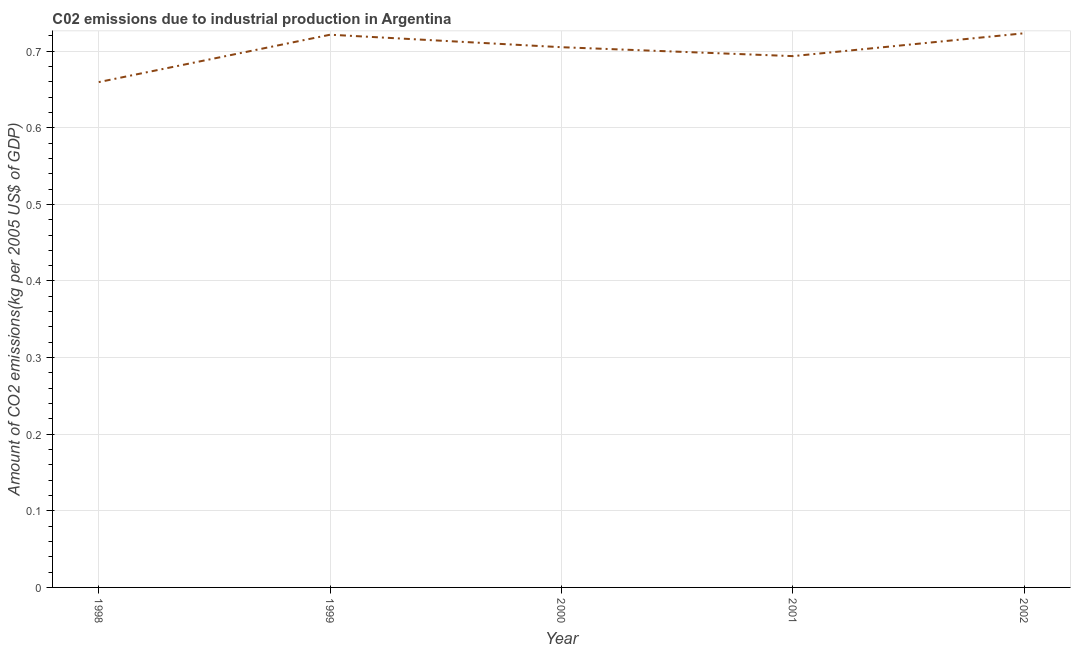What is the amount of co2 emissions in 2001?
Your answer should be very brief. 0.69. Across all years, what is the maximum amount of co2 emissions?
Your response must be concise. 0.72. Across all years, what is the minimum amount of co2 emissions?
Your answer should be very brief. 0.66. What is the sum of the amount of co2 emissions?
Your response must be concise. 3.5. What is the difference between the amount of co2 emissions in 1998 and 2002?
Provide a short and direct response. -0.06. What is the average amount of co2 emissions per year?
Ensure brevity in your answer.  0.7. What is the median amount of co2 emissions?
Keep it short and to the point. 0.71. What is the ratio of the amount of co2 emissions in 1999 to that in 2002?
Your answer should be compact. 1. Is the difference between the amount of co2 emissions in 1999 and 2001 greater than the difference between any two years?
Offer a very short reply. No. What is the difference between the highest and the second highest amount of co2 emissions?
Your answer should be very brief. 0. What is the difference between the highest and the lowest amount of co2 emissions?
Provide a succinct answer. 0.06. In how many years, is the amount of co2 emissions greater than the average amount of co2 emissions taken over all years?
Give a very brief answer. 3. How many lines are there?
Offer a very short reply. 1. Are the values on the major ticks of Y-axis written in scientific E-notation?
Ensure brevity in your answer.  No. What is the title of the graph?
Make the answer very short. C02 emissions due to industrial production in Argentina. What is the label or title of the Y-axis?
Provide a succinct answer. Amount of CO2 emissions(kg per 2005 US$ of GDP). What is the Amount of CO2 emissions(kg per 2005 US$ of GDP) in 1998?
Make the answer very short. 0.66. What is the Amount of CO2 emissions(kg per 2005 US$ of GDP) in 1999?
Offer a very short reply. 0.72. What is the Amount of CO2 emissions(kg per 2005 US$ of GDP) of 2000?
Provide a short and direct response. 0.71. What is the Amount of CO2 emissions(kg per 2005 US$ of GDP) in 2001?
Provide a short and direct response. 0.69. What is the Amount of CO2 emissions(kg per 2005 US$ of GDP) of 2002?
Your response must be concise. 0.72. What is the difference between the Amount of CO2 emissions(kg per 2005 US$ of GDP) in 1998 and 1999?
Provide a succinct answer. -0.06. What is the difference between the Amount of CO2 emissions(kg per 2005 US$ of GDP) in 1998 and 2000?
Offer a very short reply. -0.05. What is the difference between the Amount of CO2 emissions(kg per 2005 US$ of GDP) in 1998 and 2001?
Provide a short and direct response. -0.03. What is the difference between the Amount of CO2 emissions(kg per 2005 US$ of GDP) in 1998 and 2002?
Your answer should be very brief. -0.06. What is the difference between the Amount of CO2 emissions(kg per 2005 US$ of GDP) in 1999 and 2000?
Keep it short and to the point. 0.02. What is the difference between the Amount of CO2 emissions(kg per 2005 US$ of GDP) in 1999 and 2001?
Make the answer very short. 0.03. What is the difference between the Amount of CO2 emissions(kg per 2005 US$ of GDP) in 1999 and 2002?
Offer a very short reply. -0. What is the difference between the Amount of CO2 emissions(kg per 2005 US$ of GDP) in 2000 and 2001?
Keep it short and to the point. 0.01. What is the difference between the Amount of CO2 emissions(kg per 2005 US$ of GDP) in 2000 and 2002?
Provide a succinct answer. -0.02. What is the difference between the Amount of CO2 emissions(kg per 2005 US$ of GDP) in 2001 and 2002?
Your response must be concise. -0.03. What is the ratio of the Amount of CO2 emissions(kg per 2005 US$ of GDP) in 1998 to that in 1999?
Give a very brief answer. 0.91. What is the ratio of the Amount of CO2 emissions(kg per 2005 US$ of GDP) in 1998 to that in 2000?
Give a very brief answer. 0.94. What is the ratio of the Amount of CO2 emissions(kg per 2005 US$ of GDP) in 1998 to that in 2001?
Give a very brief answer. 0.95. What is the ratio of the Amount of CO2 emissions(kg per 2005 US$ of GDP) in 1998 to that in 2002?
Provide a succinct answer. 0.91. What is the ratio of the Amount of CO2 emissions(kg per 2005 US$ of GDP) in 1999 to that in 2000?
Provide a succinct answer. 1.02. What is the ratio of the Amount of CO2 emissions(kg per 2005 US$ of GDP) in 1999 to that in 2001?
Keep it short and to the point. 1.04. What is the ratio of the Amount of CO2 emissions(kg per 2005 US$ of GDP) in 2001 to that in 2002?
Ensure brevity in your answer.  0.96. 